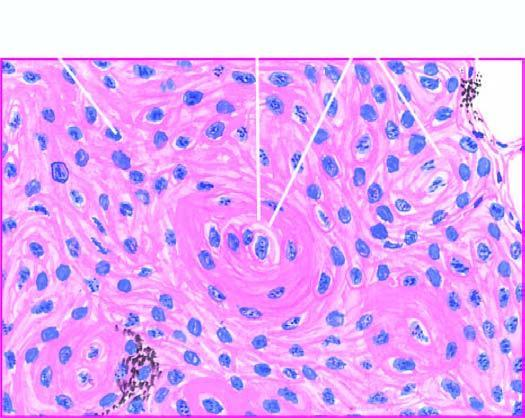what are seen?
Answer the question using a single word or phrase. Islands of invading malignant squamous cells 